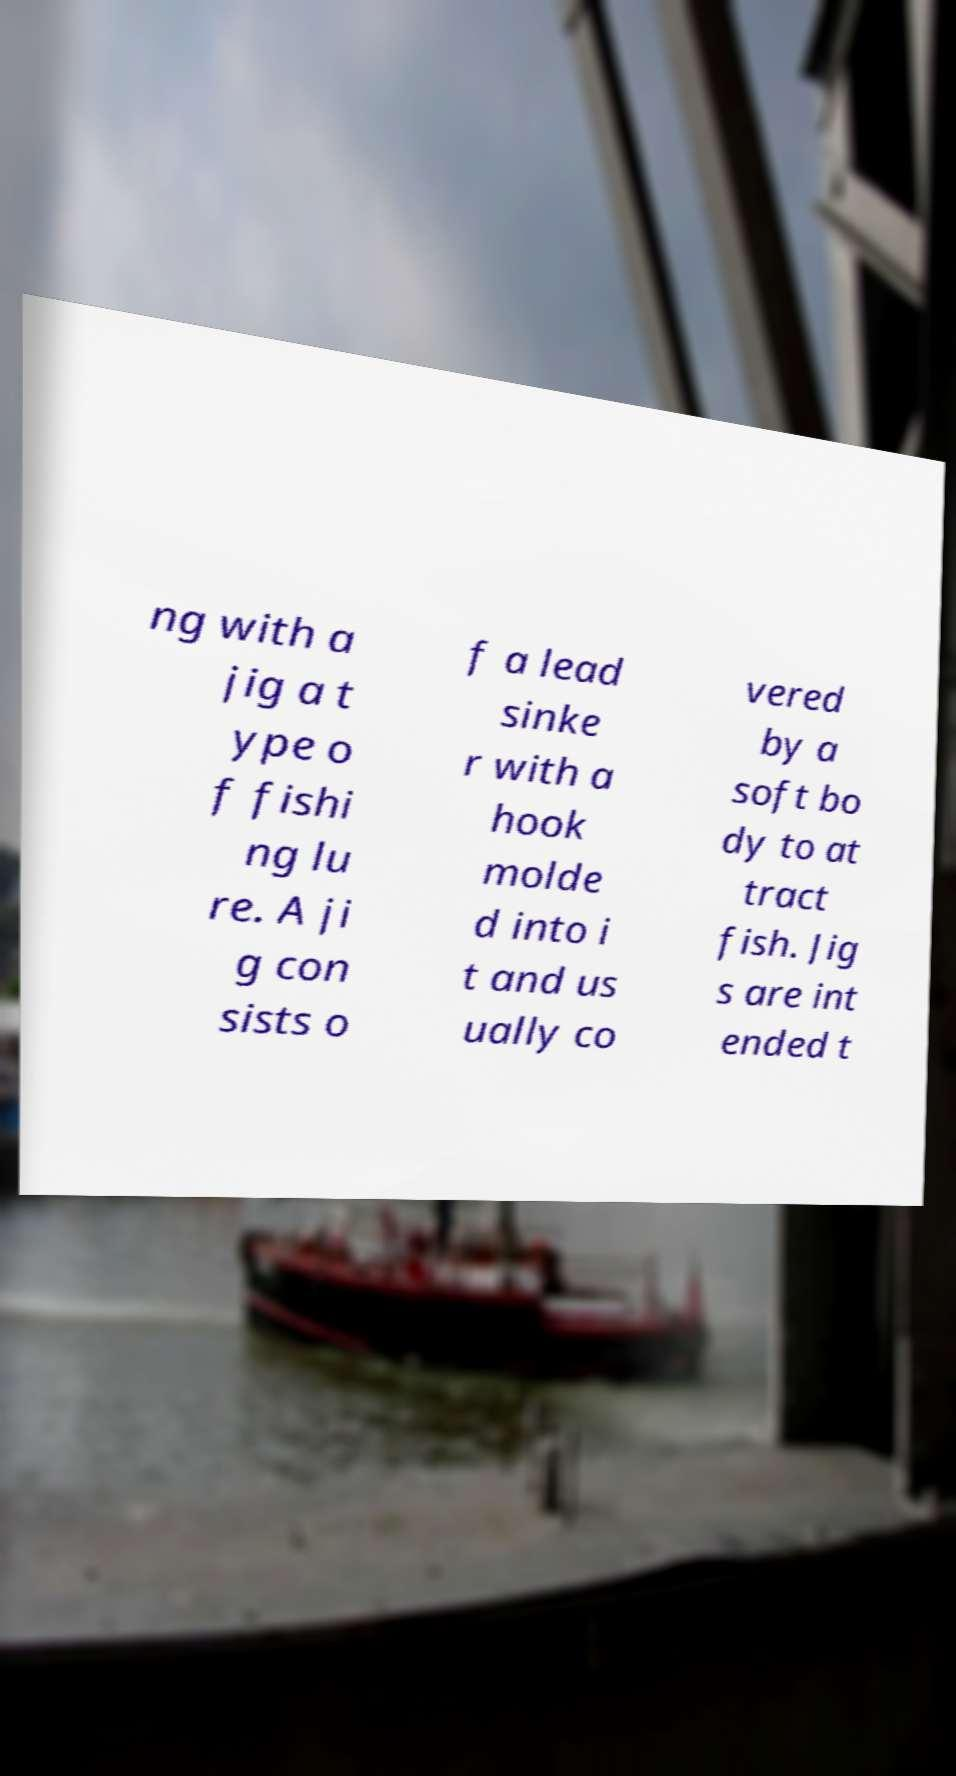Can you read and provide the text displayed in the image?This photo seems to have some interesting text. Can you extract and type it out for me? ng with a jig a t ype o f fishi ng lu re. A ji g con sists o f a lead sinke r with a hook molde d into i t and us ually co vered by a soft bo dy to at tract fish. Jig s are int ended t 